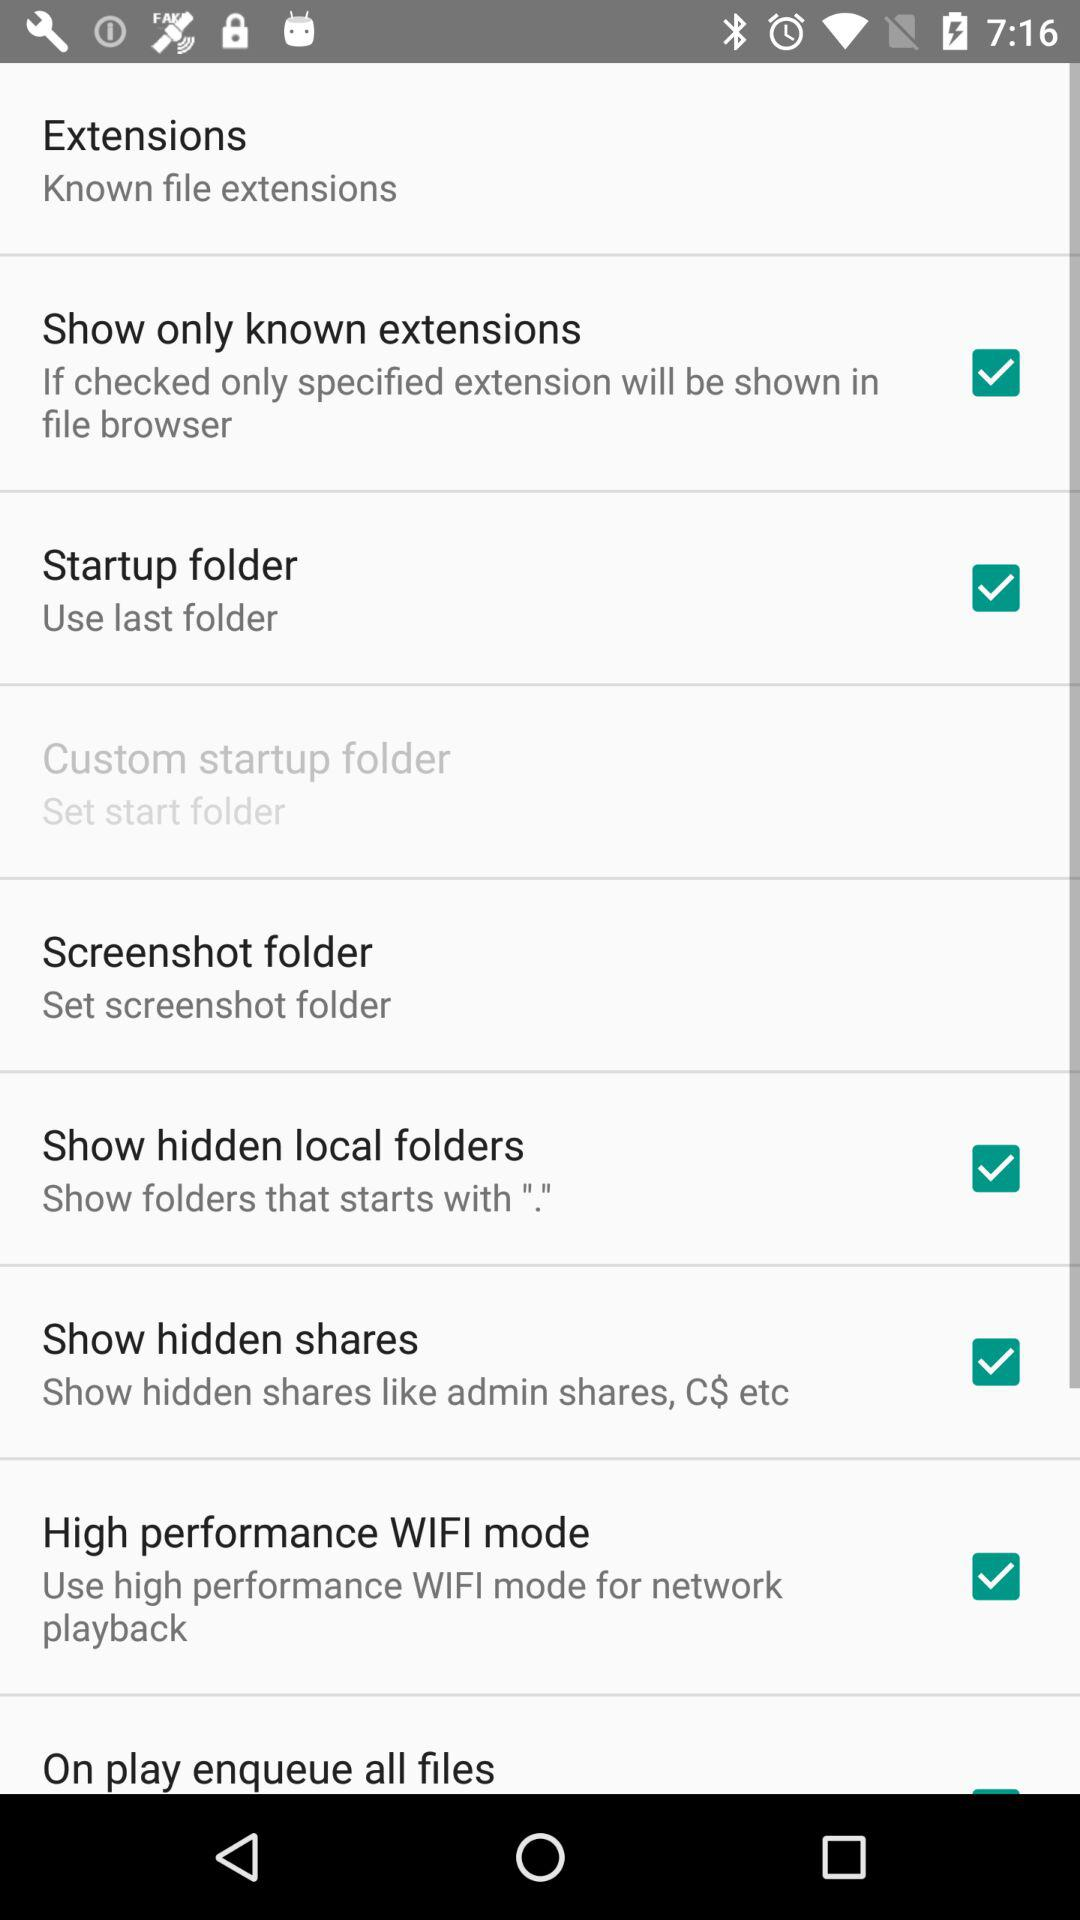What is the setting for "Show hidden shares"? The setting is "Show hidden shares like admin shares, C$ etc". 